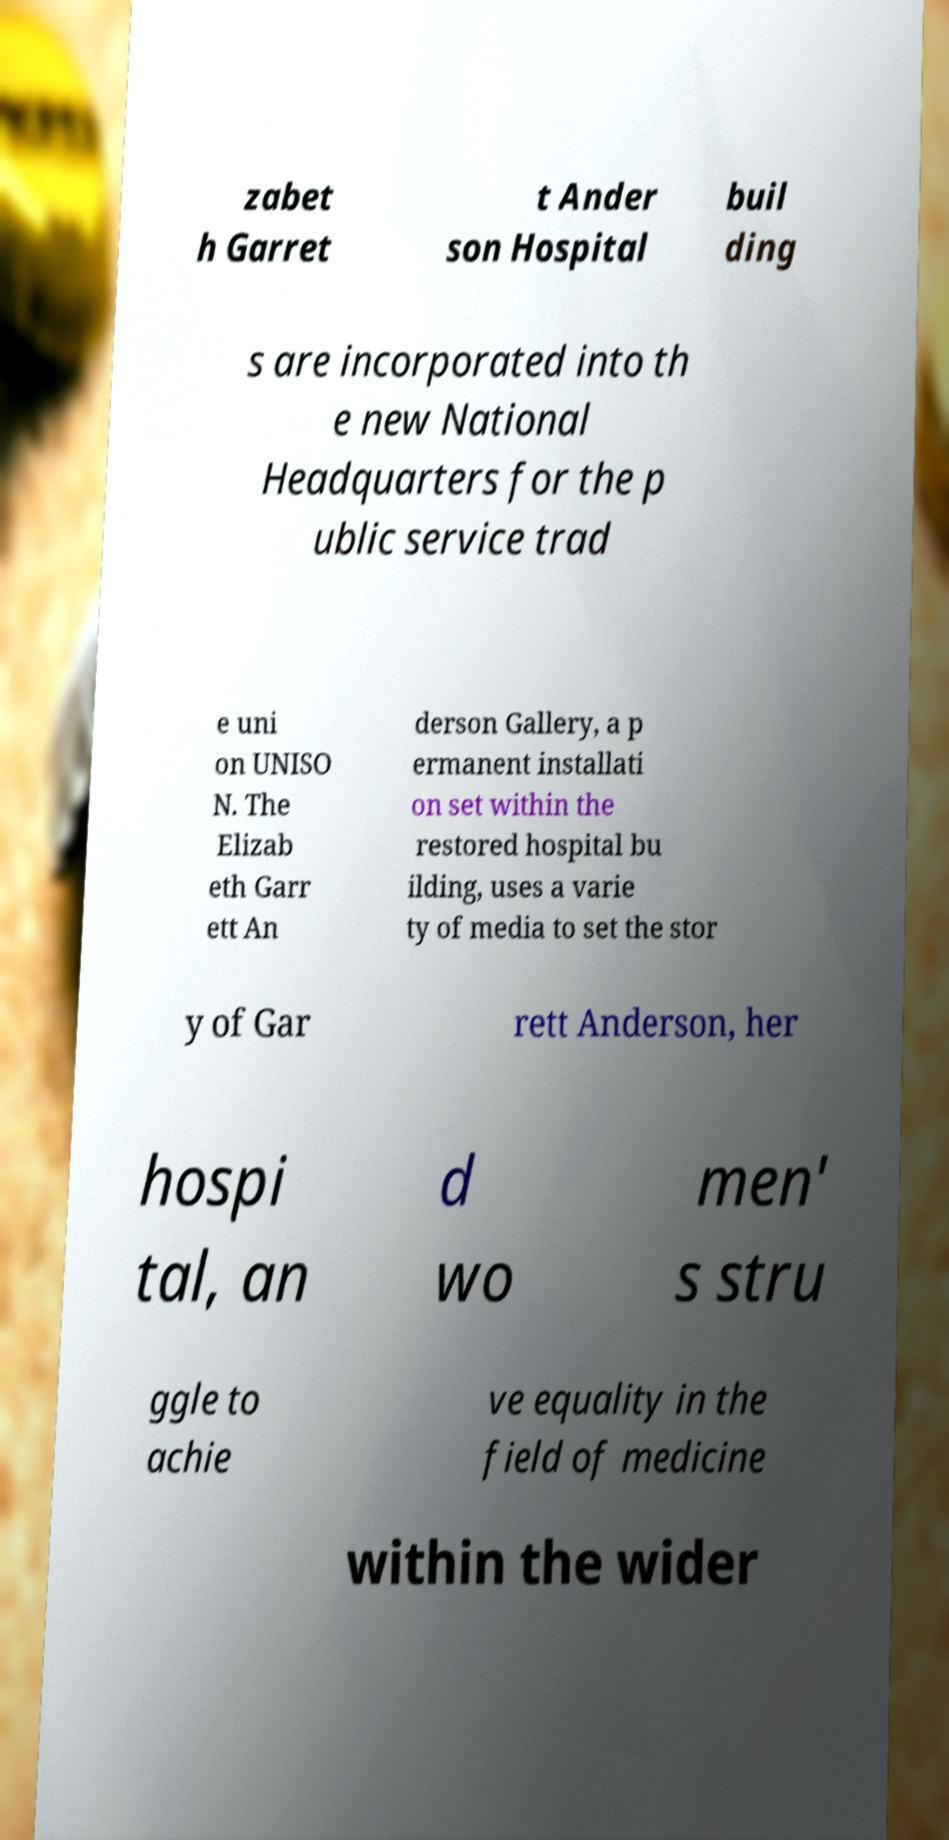Could you extract and type out the text from this image? zabet h Garret t Ander son Hospital buil ding s are incorporated into th e new National Headquarters for the p ublic service trad e uni on UNISO N. The Elizab eth Garr ett An derson Gallery, a p ermanent installati on set within the restored hospital bu ilding, uses a varie ty of media to set the stor y of Gar rett Anderson, her hospi tal, an d wo men' s stru ggle to achie ve equality in the field of medicine within the wider 